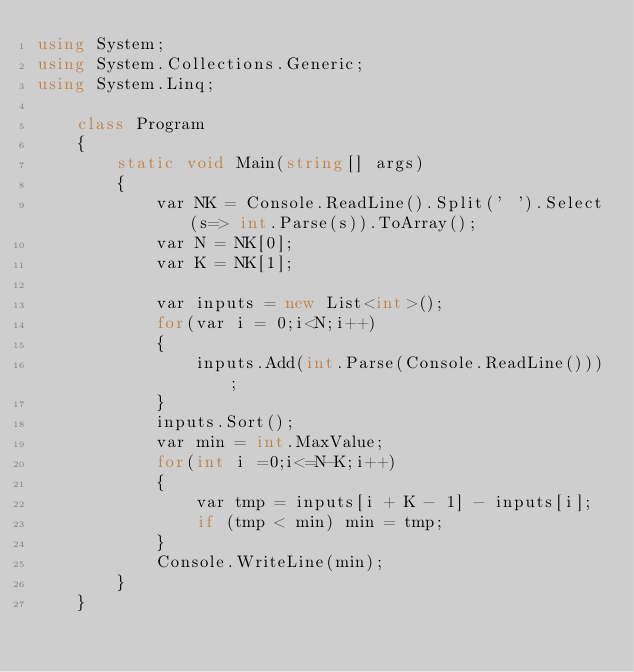Convert code to text. <code><loc_0><loc_0><loc_500><loc_500><_C#_>using System;
using System.Collections.Generic;
using System.Linq;

    class Program
    {
        static void Main(string[] args)
        {
            var NK = Console.ReadLine().Split(' ').Select(s=> int.Parse(s)).ToArray();
            var N = NK[0];
            var K = NK[1];

            var inputs = new List<int>();
            for(var i = 0;i<N;i++)
            {
                inputs.Add(int.Parse(Console.ReadLine()));
            }
            inputs.Sort();
            var min = int.MaxValue;
            for(int i =0;i<=N-K;i++)
            {
                var tmp = inputs[i + K - 1] - inputs[i];
                if (tmp < min) min = tmp;
            }
            Console.WriteLine(min);
        }
    }</code> 